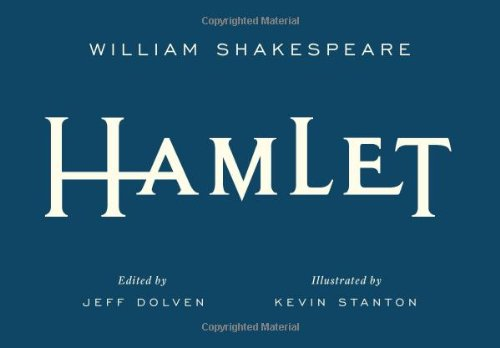What is the genre of this book? The genre of 'Hamlet' is Literature & Fiction, specifically within the sub-genre of tragic plays. 